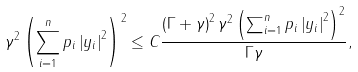<formula> <loc_0><loc_0><loc_500><loc_500>\gamma ^ { 2 } \left ( \sum _ { i = 1 } ^ { n } p _ { i } \left | y _ { i } \right | ^ { 2 } \right ) ^ { 2 } \leq C \frac { \left ( \Gamma + \gamma \right ) ^ { 2 } \gamma ^ { 2 } \left ( \sum _ { i = 1 } ^ { n } p _ { i } \left | y _ { i } \right | ^ { 2 } \right ) ^ { 2 } } { \Gamma \gamma } ,</formula> 